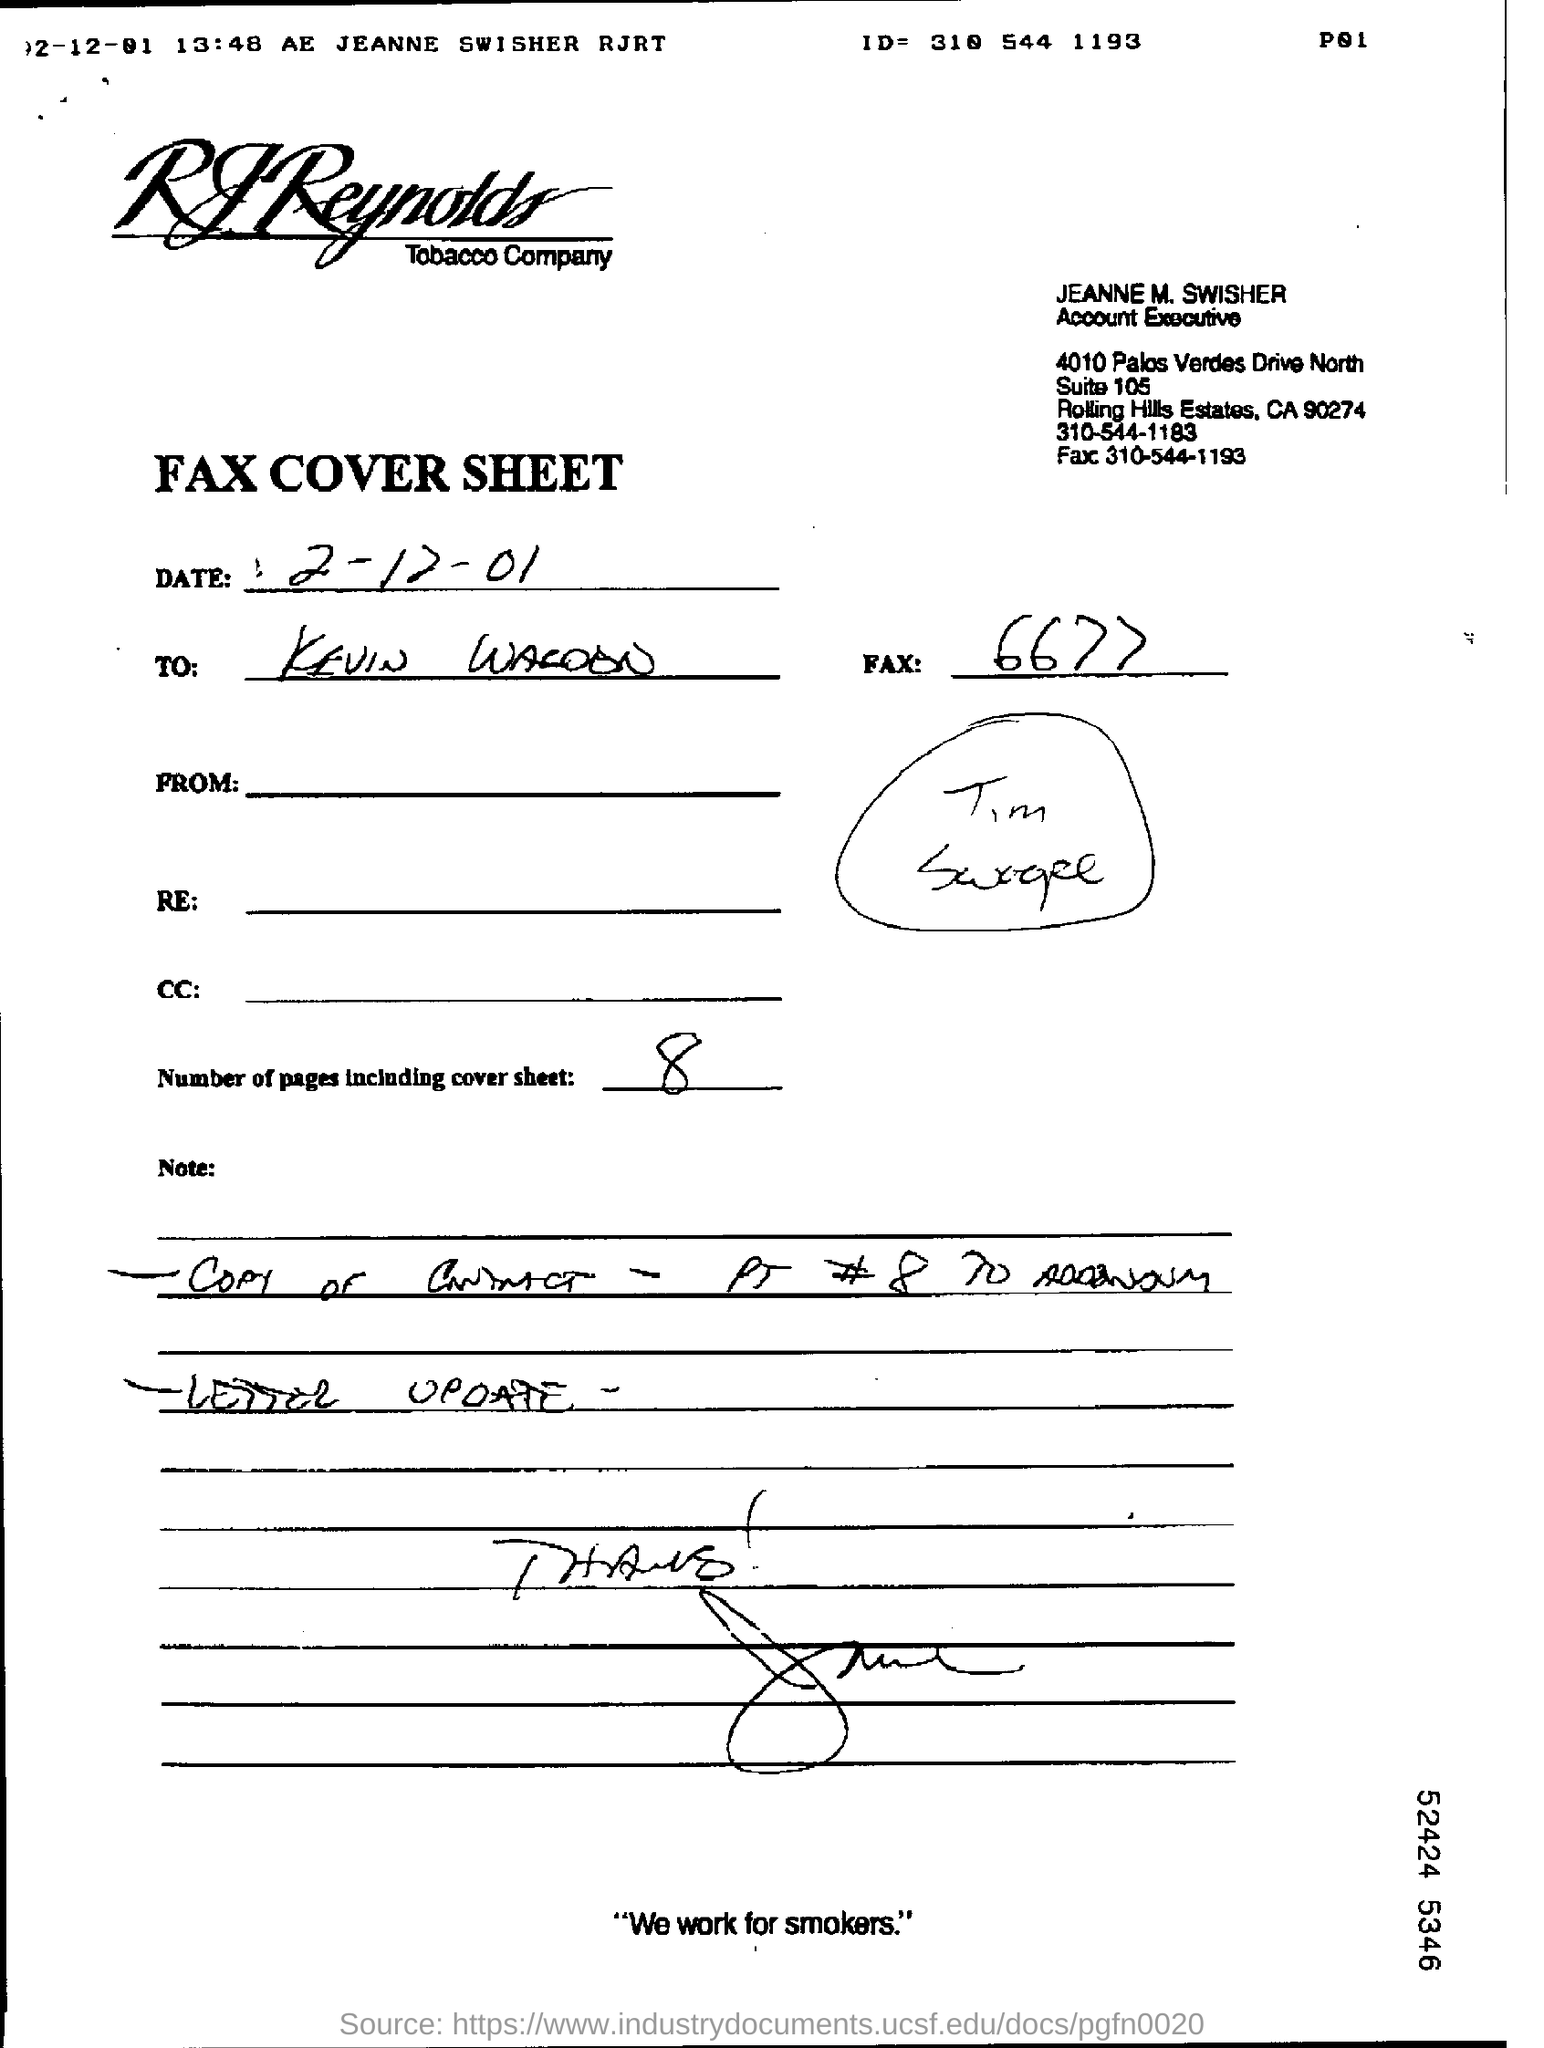Specify some key components in this picture. The contact number of Jeanne M. Swisher is 310-544-1183. The total number of pages, including the cover sheet, is 8. Jeanne M. Swisher is an account executive. The name of the company is RJReynolds Tobacco Company. 